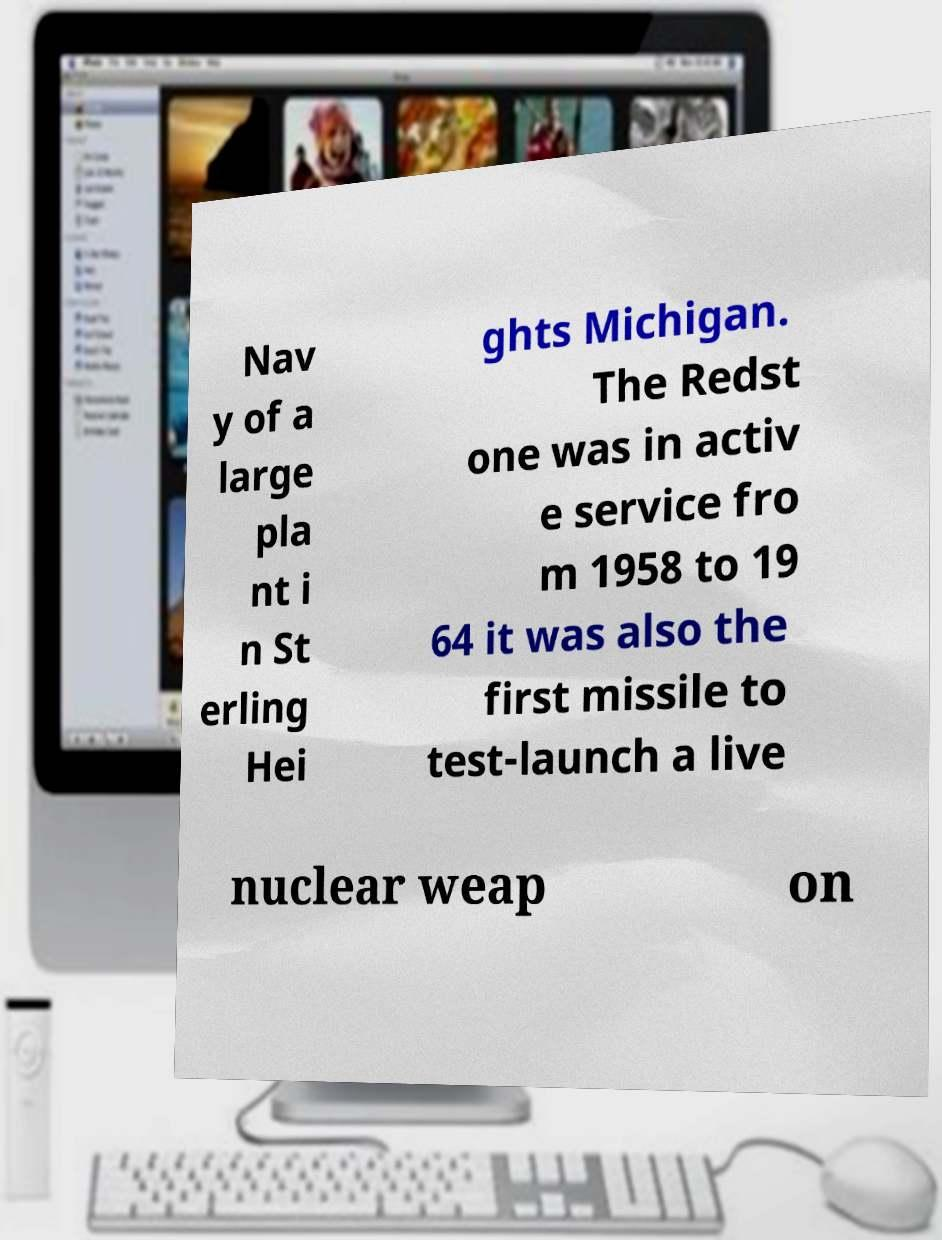Please identify and transcribe the text found in this image. Nav y of a large pla nt i n St erling Hei ghts Michigan. The Redst one was in activ e service fro m 1958 to 19 64 it was also the first missile to test-launch a live nuclear weap on 